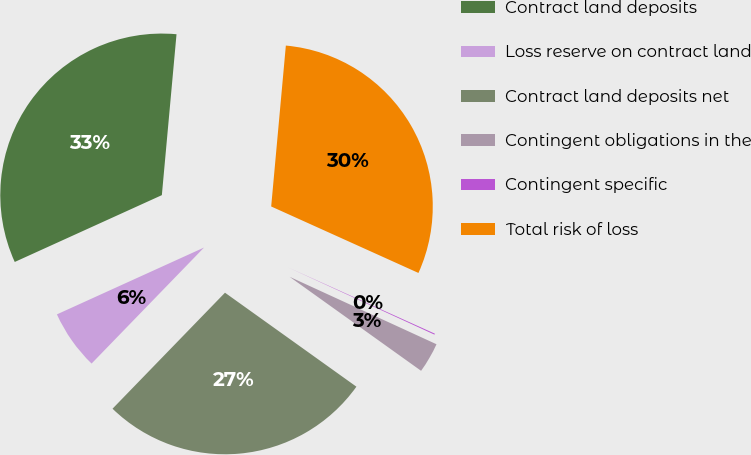Convert chart. <chart><loc_0><loc_0><loc_500><loc_500><pie_chart><fcel>Contract land deposits<fcel>Loss reserve on contract land<fcel>Contract land deposits net<fcel>Contingent obligations in the<fcel>Contingent specific<fcel>Total risk of loss<nl><fcel>33.23%<fcel>5.96%<fcel>27.37%<fcel>3.03%<fcel>0.1%<fcel>30.3%<nl></chart> 